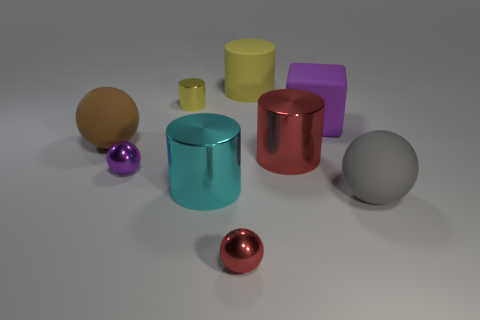Subtract all cubes. How many objects are left? 8 Add 7 matte cylinders. How many matte cylinders are left? 8 Add 4 big blue cylinders. How many big blue cylinders exist? 4 Subtract 1 red balls. How many objects are left? 8 Subtract all cyan metal cubes. Subtract all large yellow rubber objects. How many objects are left? 8 